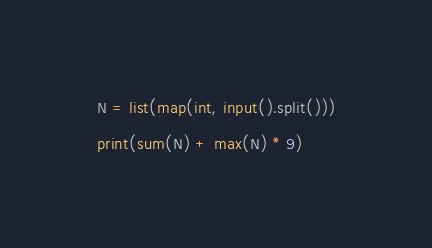Convert code to text. <code><loc_0><loc_0><loc_500><loc_500><_Python_>N = list(map(int, input().split()))

print(sum(N) + max(N) * 9)</code> 